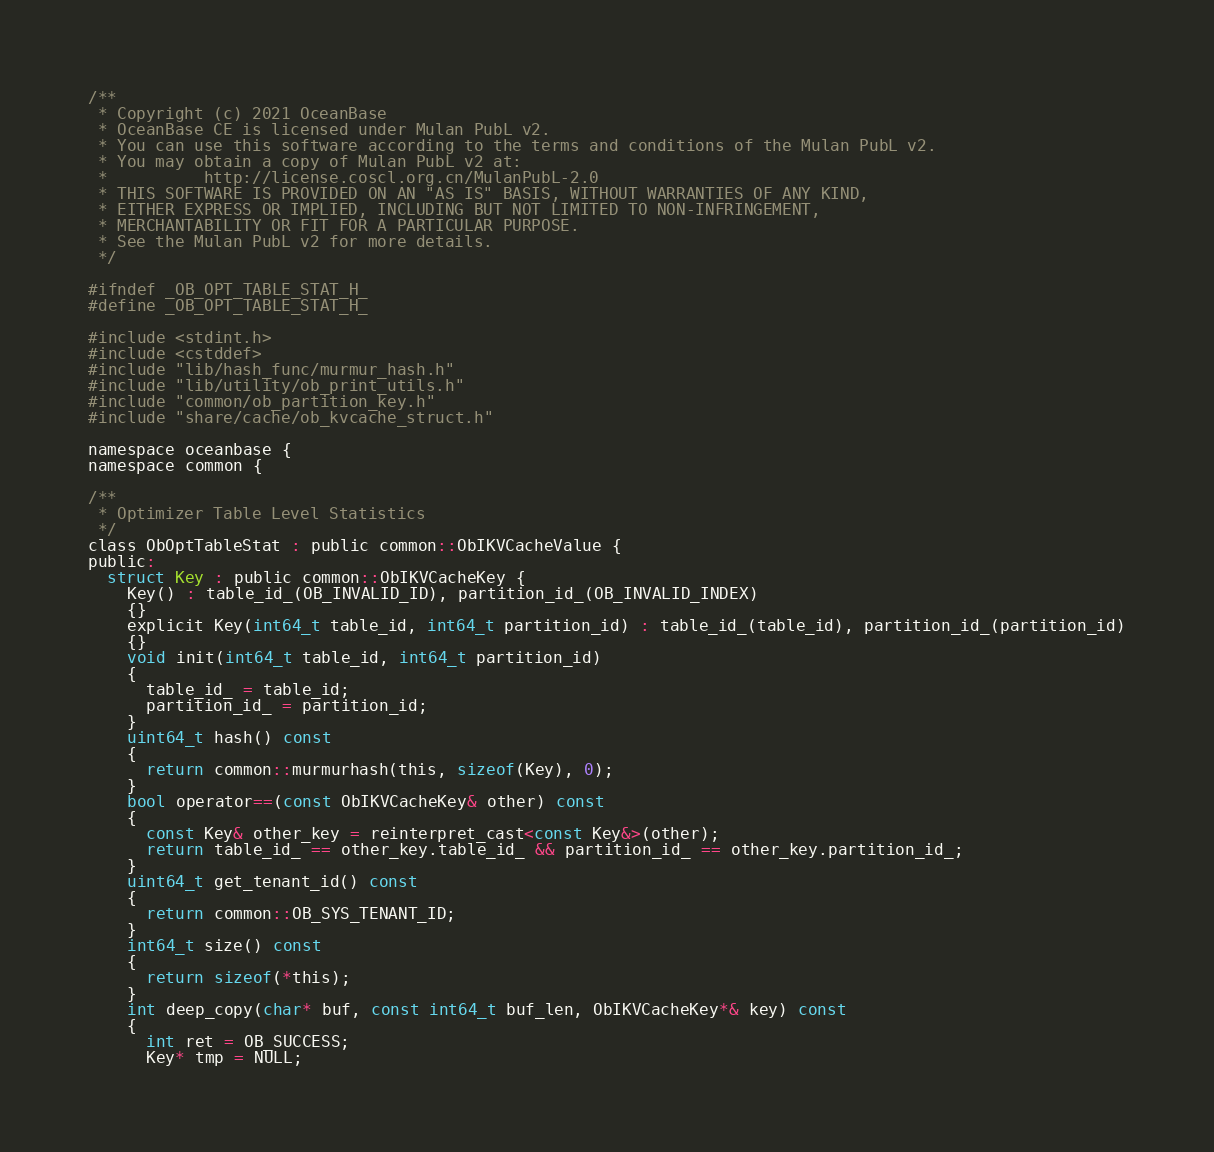<code> <loc_0><loc_0><loc_500><loc_500><_C_>/**
 * Copyright (c) 2021 OceanBase
 * OceanBase CE is licensed under Mulan PubL v2.
 * You can use this software according to the terms and conditions of the Mulan PubL v2.
 * You may obtain a copy of Mulan PubL v2 at:
 *          http://license.coscl.org.cn/MulanPubL-2.0
 * THIS SOFTWARE IS PROVIDED ON AN "AS IS" BASIS, WITHOUT WARRANTIES OF ANY KIND,
 * EITHER EXPRESS OR IMPLIED, INCLUDING BUT NOT LIMITED TO NON-INFRINGEMENT,
 * MERCHANTABILITY OR FIT FOR A PARTICULAR PURPOSE.
 * See the Mulan PubL v2 for more details.
 */

#ifndef _OB_OPT_TABLE_STAT_H_
#define _OB_OPT_TABLE_STAT_H_

#include <stdint.h>
#include <cstddef>
#include "lib/hash_func/murmur_hash.h"
#include "lib/utility/ob_print_utils.h"
#include "common/ob_partition_key.h"
#include "share/cache/ob_kvcache_struct.h"

namespace oceanbase {
namespace common {

/**
 * Optimizer Table Level Statistics
 */
class ObOptTableStat : public common::ObIKVCacheValue {
public:
  struct Key : public common::ObIKVCacheKey {
    Key() : table_id_(OB_INVALID_ID), partition_id_(OB_INVALID_INDEX)
    {}
    explicit Key(int64_t table_id, int64_t partition_id) : table_id_(table_id), partition_id_(partition_id)
    {}
    void init(int64_t table_id, int64_t partition_id)
    {
      table_id_ = table_id;
      partition_id_ = partition_id;
    }
    uint64_t hash() const
    {
      return common::murmurhash(this, sizeof(Key), 0);
    }
    bool operator==(const ObIKVCacheKey& other) const
    {
      const Key& other_key = reinterpret_cast<const Key&>(other);
      return table_id_ == other_key.table_id_ && partition_id_ == other_key.partition_id_;
    }
    uint64_t get_tenant_id() const
    {
      return common::OB_SYS_TENANT_ID;
    }
    int64_t size() const
    {
      return sizeof(*this);
    }
    int deep_copy(char* buf, const int64_t buf_len, ObIKVCacheKey*& key) const
    {
      int ret = OB_SUCCESS;
      Key* tmp = NULL;</code> 